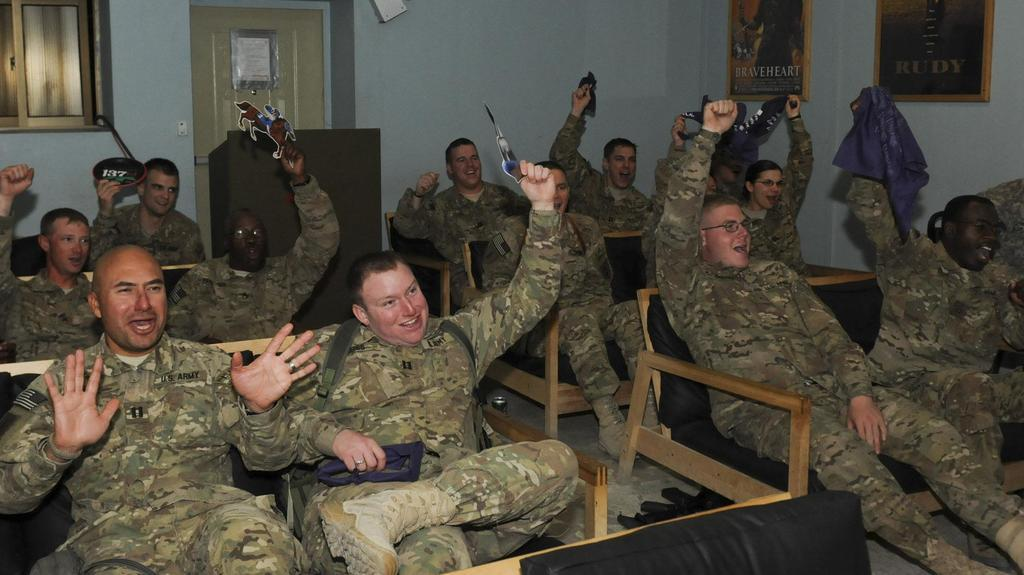What is the main subject of the image? The main subject of the image is a group of soldiers. What are the soldiers doing in the image? The soldiers are seated on chairs in the image. How are the soldiers feeling in the image? The soldiers have smiles on their faces, indicating that they are happy or content. What type of committee can be seen in the image? There is no committee present in the image; it features a group of soldiers seated on chairs. How many shelves are visible in the image? There are no shelves visible in the image. 